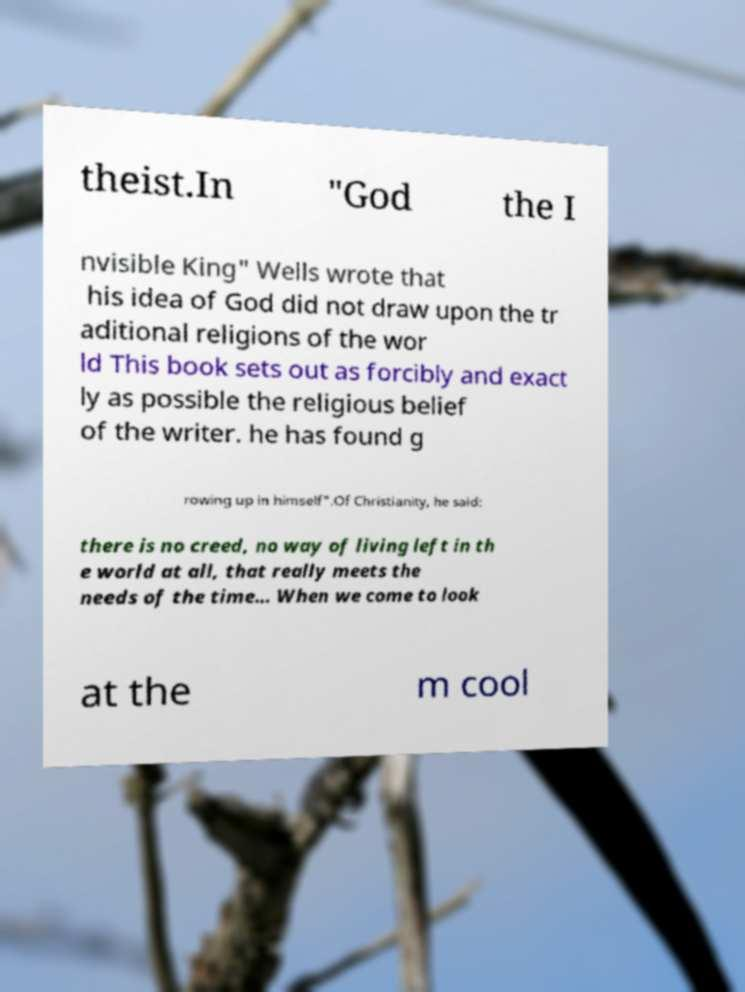Could you extract and type out the text from this image? theist.In "God the I nvisible King" Wells wrote that his idea of God did not draw upon the tr aditional religions of the wor ld This book sets out as forcibly and exact ly as possible the religious belief of the writer. he has found g rowing up in himself".Of Christianity, he said: there is no creed, no way of living left in th e world at all, that really meets the needs of the time… When we come to look at the m cool 